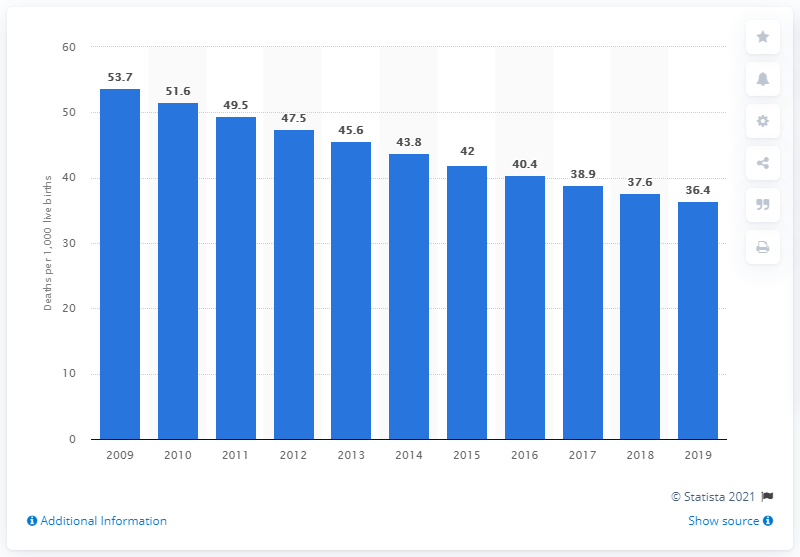Highlight a few significant elements in this photo. According to data from 2019, the infant mortality rate in Laos was 36.4 deaths per 1,000 live births. 